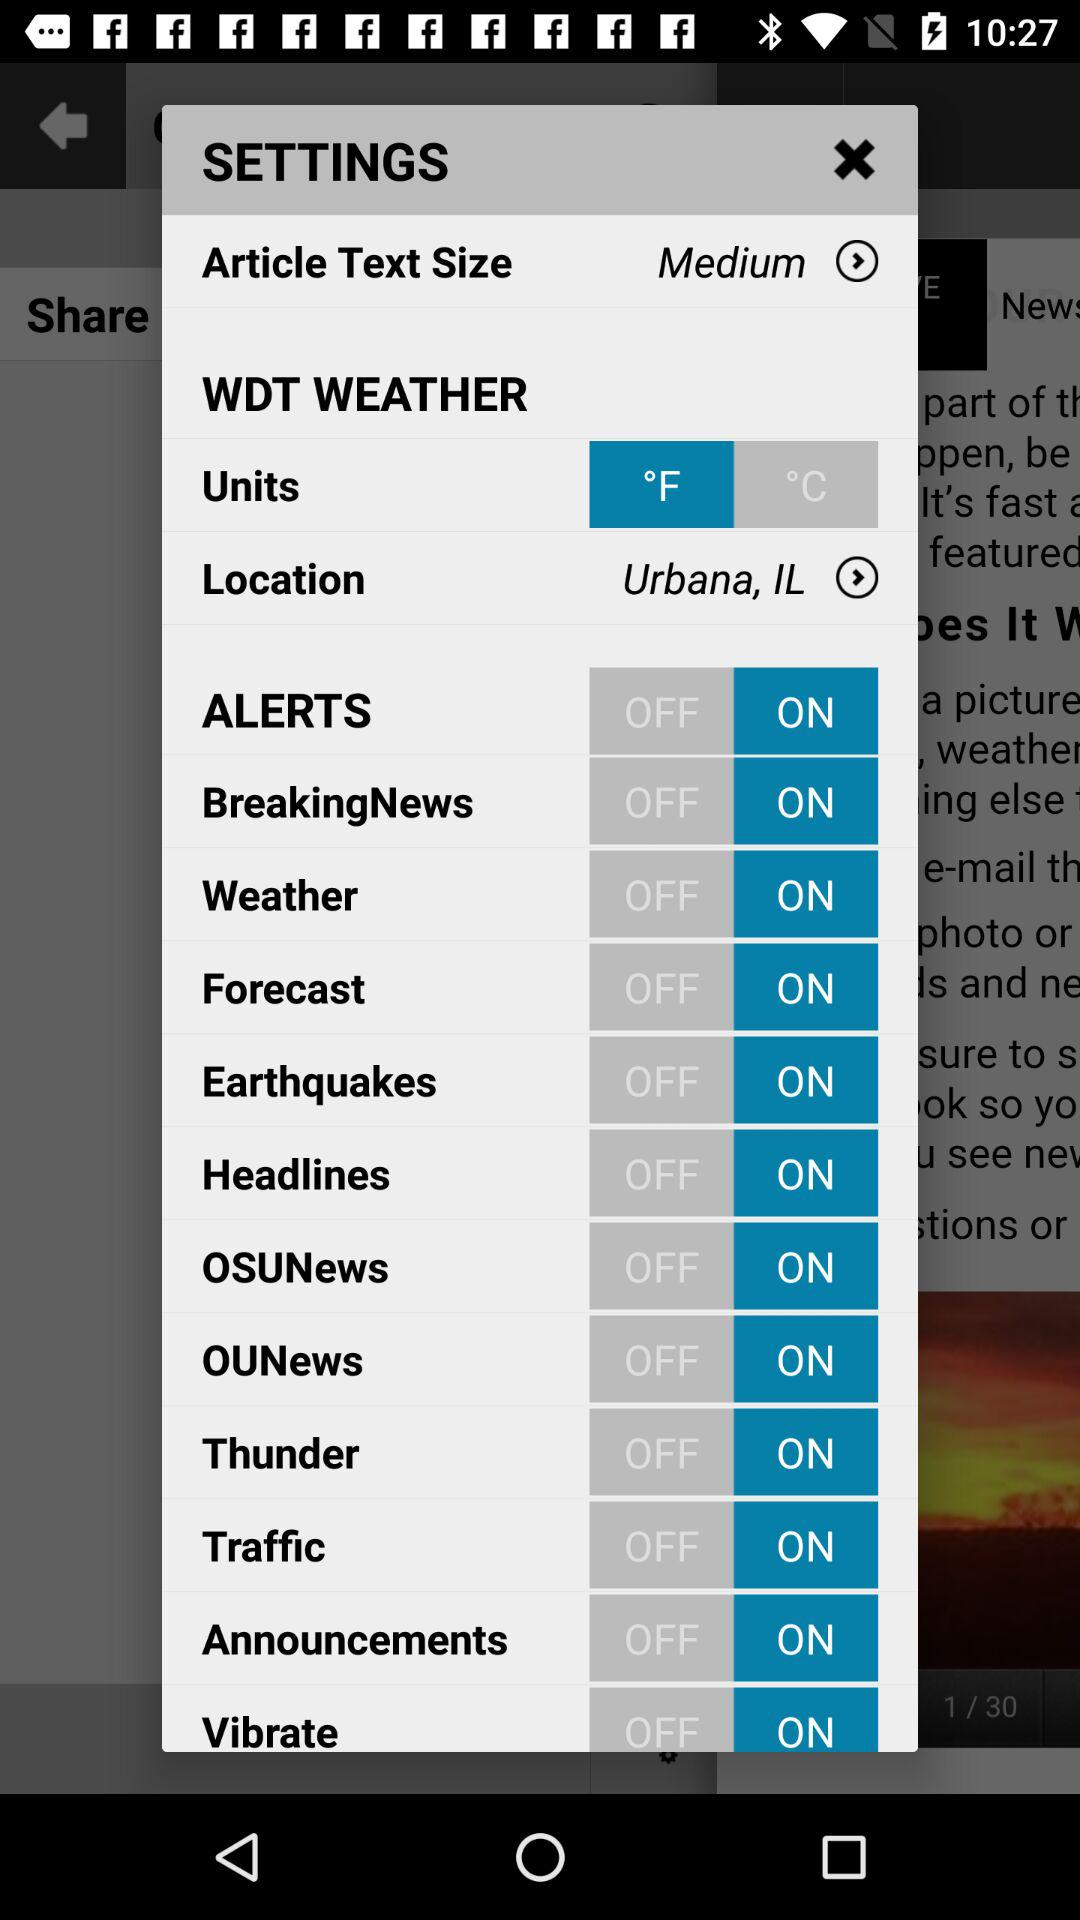What is the status of "Weather"? The status of "Weather" is "on". 